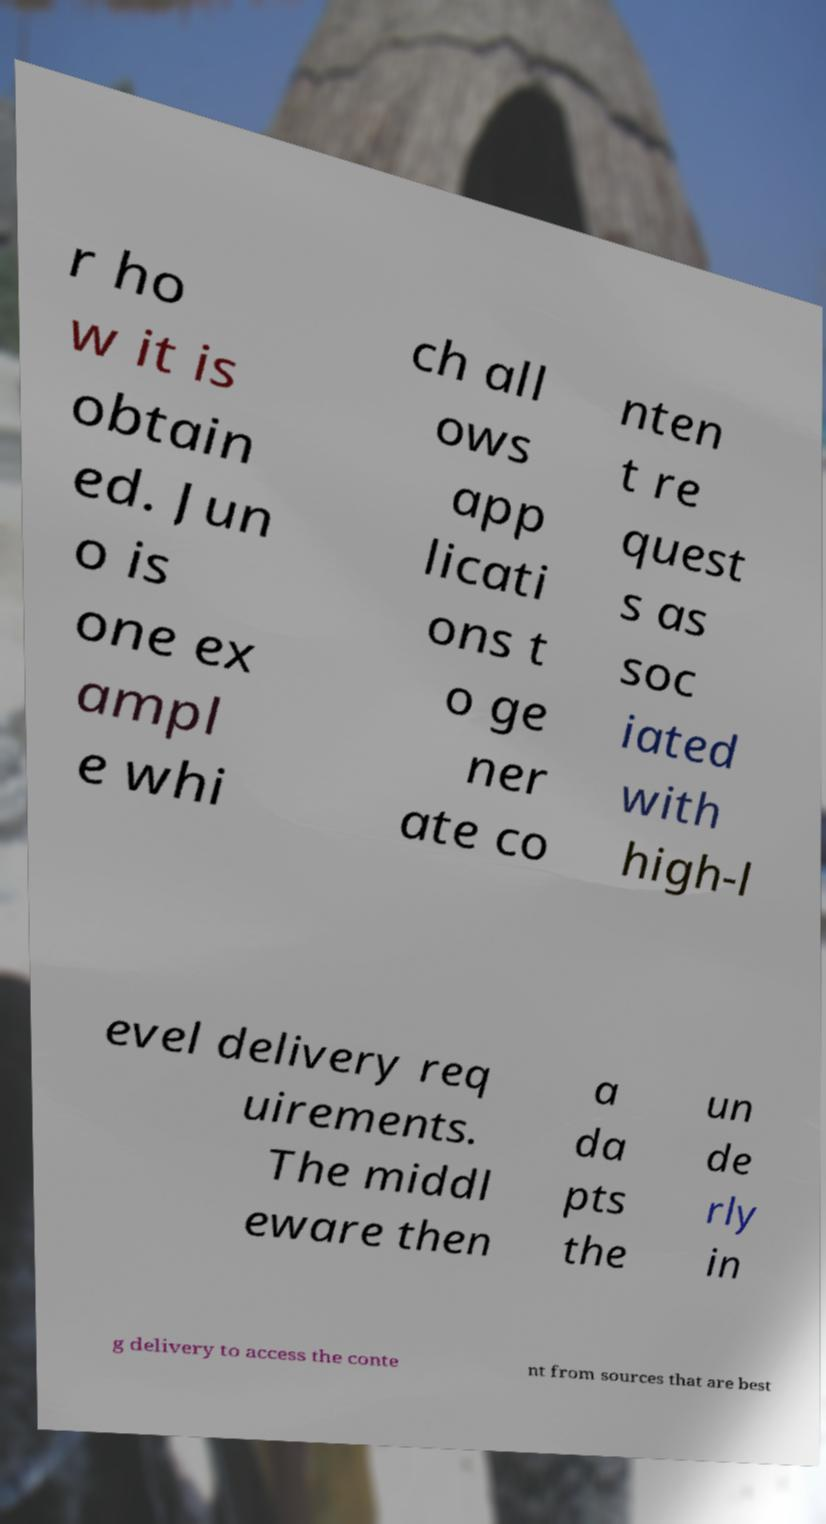Can you accurately transcribe the text from the provided image for me? r ho w it is obtain ed. Jun o is one ex ampl e whi ch all ows app licati ons t o ge ner ate co nten t re quest s as soc iated with high-l evel delivery req uirements. The middl eware then a da pts the un de rly in g delivery to access the conte nt from sources that are best 